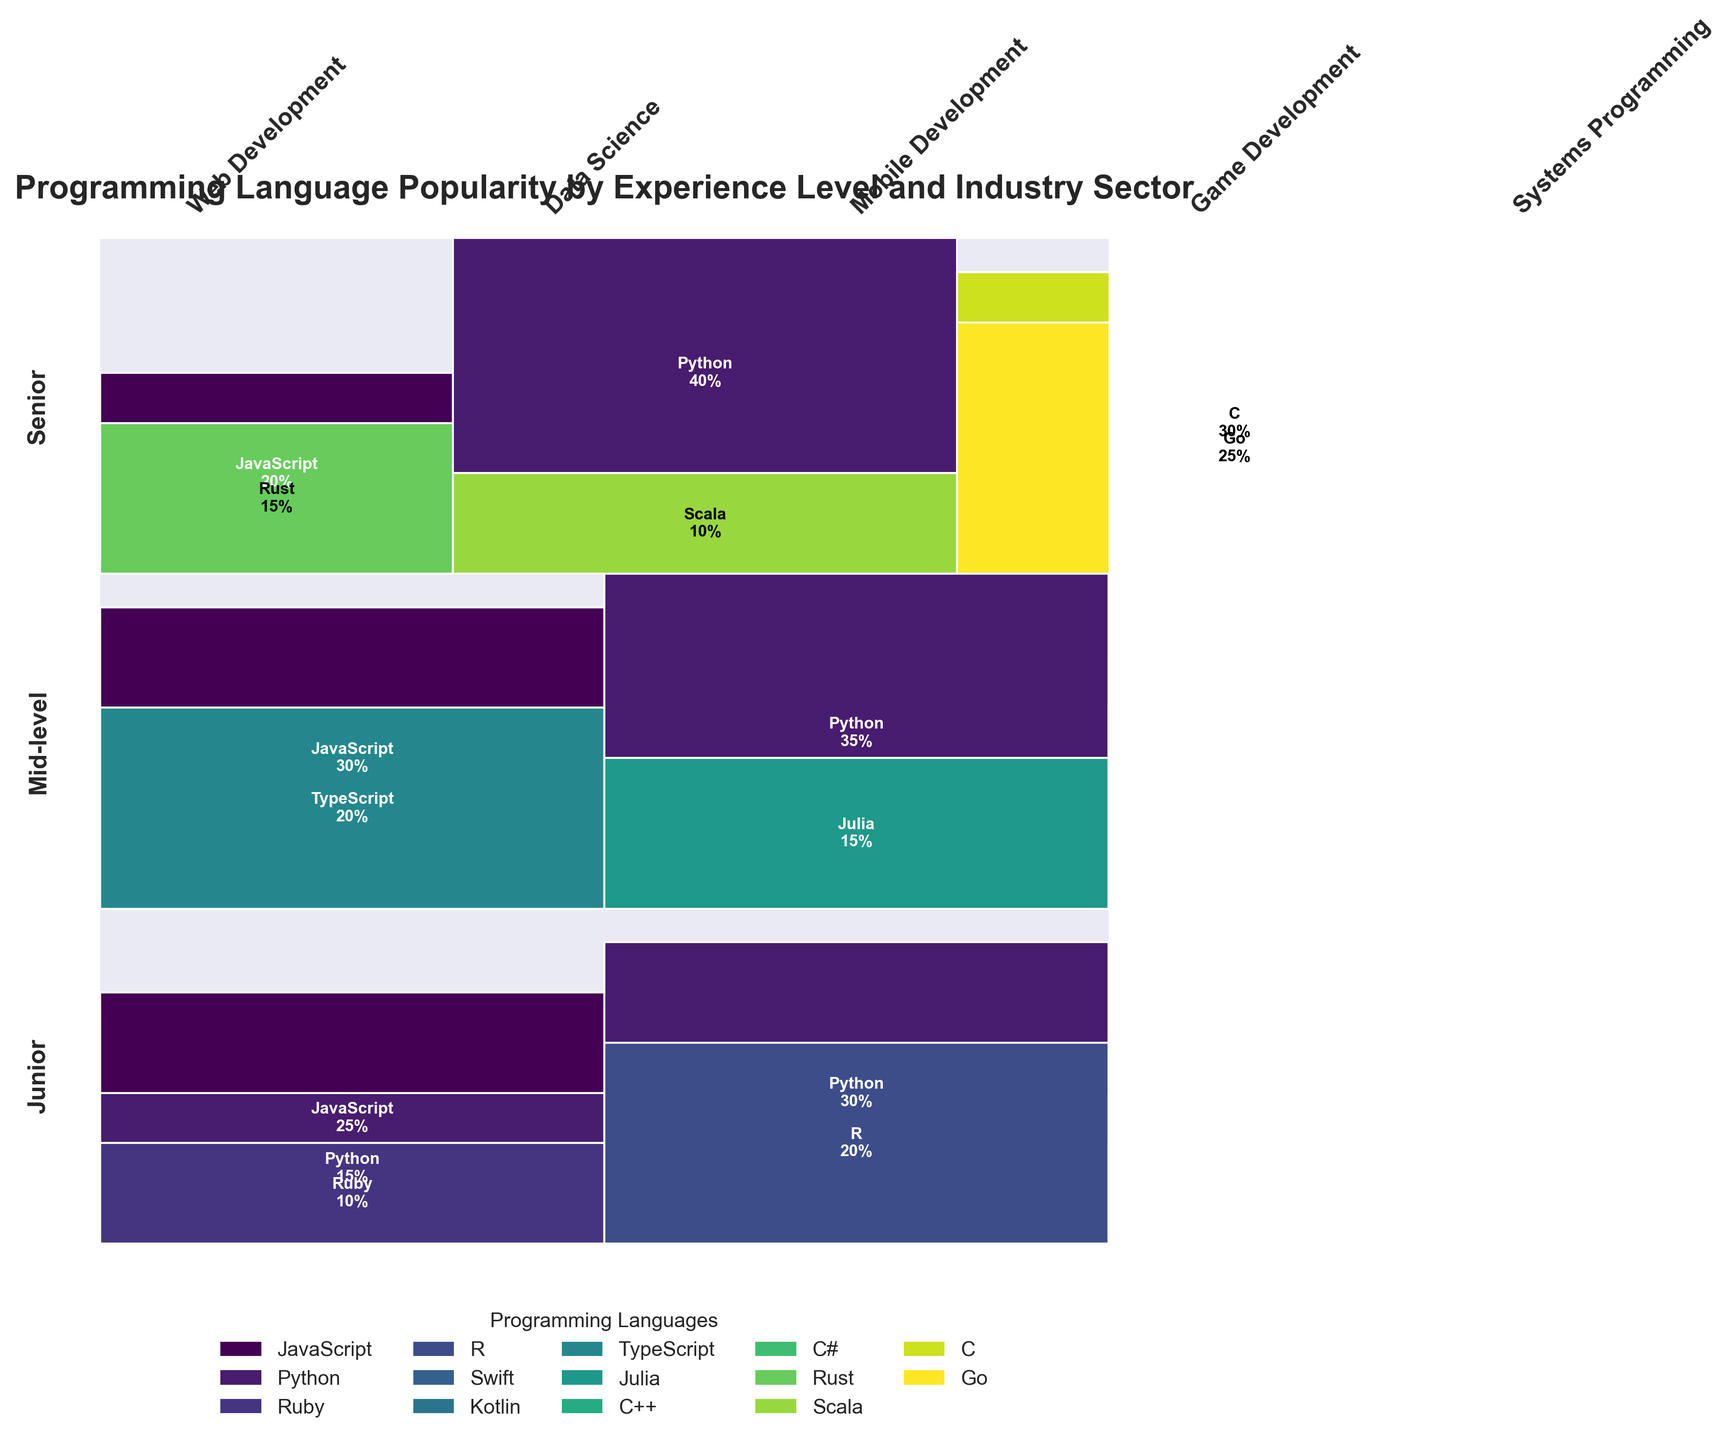What is the most popular programming language among senior developers in Data Science? To answer this, locate the section for "Senior" and then find the "Data Science" column within that category. Identify which programming language has the largest area in that section.
Answer: Python Which programming language is used by juniors and mid-level developers in Web Development but not by seniors? Look at the "Web Development" section for each experience level. Compare the programming languages used by "Junior" and "Mid-level" categories with those in the "Senior" category. Identify any language present in junior or mid-level but missing in senior.
Answer: TypeScript What is the combined percentage of Python usage across all experience levels in Data Science? Identify all the sections labeled "Data Science" for each experience level. Sum the percentages for Python usage across each of these sections: Junior (30%), Mid-level (35%), Senior (40%). Add these values together.
Answer: 105% Is JavaScript used more by junior or mid-level developers in Web Development? Navigate through the “Web Development” section under both "Junior" and "Mid-level". Compare the percentage sections representing JavaScript in each category.
Answer: Mid-level Which industry sector shows the highest usage of Rust by senior developers? Focus on the sections labeled for "Senior" developers. Search through each industry sector to find where Rust appears and then identify the sector with the largest percentage.
Answer: Web Development Compare the usage of Julia and Scala among senior developers in Data Science. Which one is higher? Locate the "Senior" section and find the "Data Science" column. Compare the areas labeled with Julia and Scala within that sector.
Answer: Scala What is the total percentage of programming language usage in Mobile Development among juniors? Sum all the percentages listed under the "Mobile Development" sector within the "Junior" experience level. Specifically, add Swift (15%) and Kotlin (10%).
Answer: 25% Which programming language is the least popular among mid-level developers in Game Development? Within the "Mid-level" section, find the "Game Development" sector and compare the percentages of the programming languages used there. Identify the smallest percentage.
Answer: C# What’s the percentage difference between C and Go usage in senior Systems Programming? Find C and Go percentages under the "Senior" section in "Systems Programming". Subtract the smaller percentage (Go at 25%) from the larger percentage (C at 30%).
Answer: 5% Which language dominates in Data Science across all experience levels? Look in the "Data Science" section for each experience level and identify the language that consistently has the highest percentages overall. Compare these to determine the dominant language.
Answer: Python 